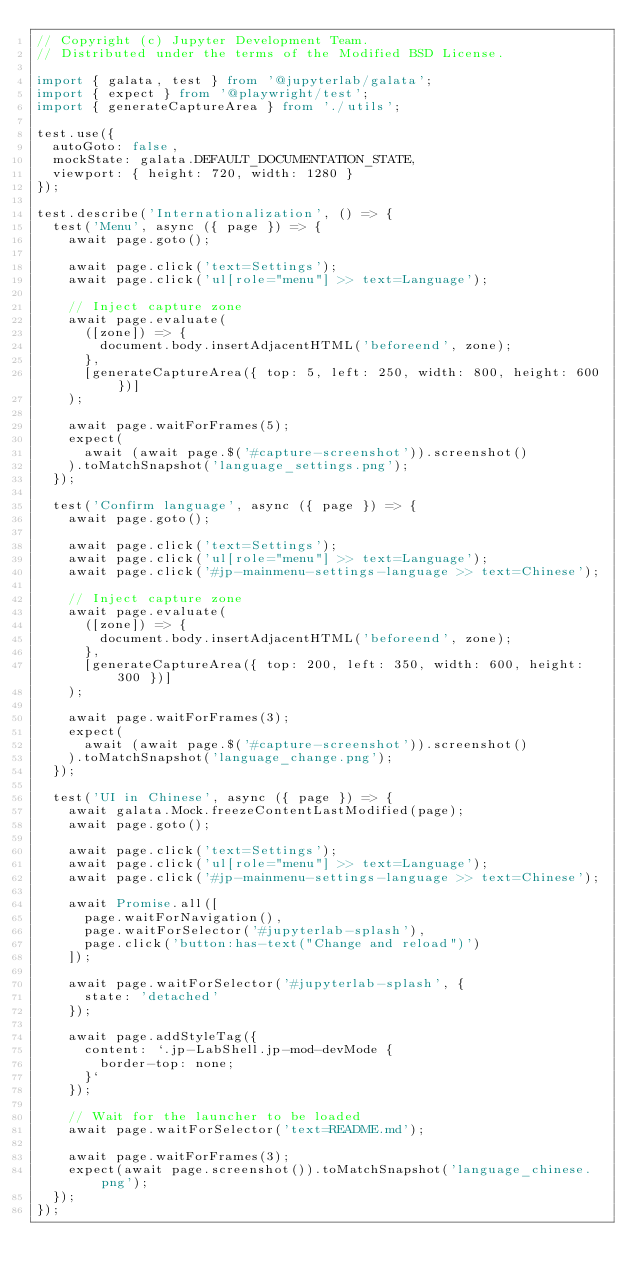<code> <loc_0><loc_0><loc_500><loc_500><_TypeScript_>// Copyright (c) Jupyter Development Team.
// Distributed under the terms of the Modified BSD License.

import { galata, test } from '@jupyterlab/galata';
import { expect } from '@playwright/test';
import { generateCaptureArea } from './utils';

test.use({
  autoGoto: false,
  mockState: galata.DEFAULT_DOCUMENTATION_STATE,
  viewport: { height: 720, width: 1280 }
});

test.describe('Internationalization', () => {
  test('Menu', async ({ page }) => {
    await page.goto();

    await page.click('text=Settings');
    await page.click('ul[role="menu"] >> text=Language');

    // Inject capture zone
    await page.evaluate(
      ([zone]) => {
        document.body.insertAdjacentHTML('beforeend', zone);
      },
      [generateCaptureArea({ top: 5, left: 250, width: 800, height: 600 })]
    );

    await page.waitForFrames(5);
    expect(
      await (await page.$('#capture-screenshot')).screenshot()
    ).toMatchSnapshot('language_settings.png');
  });

  test('Confirm language', async ({ page }) => {
    await page.goto();

    await page.click('text=Settings');
    await page.click('ul[role="menu"] >> text=Language');
    await page.click('#jp-mainmenu-settings-language >> text=Chinese');

    // Inject capture zone
    await page.evaluate(
      ([zone]) => {
        document.body.insertAdjacentHTML('beforeend', zone);
      },
      [generateCaptureArea({ top: 200, left: 350, width: 600, height: 300 })]
    );

    await page.waitForFrames(3);
    expect(
      await (await page.$('#capture-screenshot')).screenshot()
    ).toMatchSnapshot('language_change.png');
  });

  test('UI in Chinese', async ({ page }) => {
    await galata.Mock.freezeContentLastModified(page);
    await page.goto();

    await page.click('text=Settings');
    await page.click('ul[role="menu"] >> text=Language');
    await page.click('#jp-mainmenu-settings-language >> text=Chinese');

    await Promise.all([
      page.waitForNavigation(),
      page.waitForSelector('#jupyterlab-splash'),
      page.click('button:has-text("Change and reload")')
    ]);

    await page.waitForSelector('#jupyterlab-splash', {
      state: 'detached'
    });

    await page.addStyleTag({
      content: `.jp-LabShell.jp-mod-devMode {
        border-top: none;
      }`
    });

    // Wait for the launcher to be loaded
    await page.waitForSelector('text=README.md');

    await page.waitForFrames(3);
    expect(await page.screenshot()).toMatchSnapshot('language_chinese.png');
  });
});
</code> 